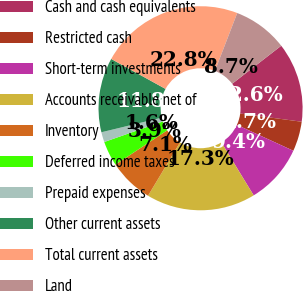<chart> <loc_0><loc_0><loc_500><loc_500><pie_chart><fcel>Cash and cash equivalents<fcel>Restricted cash<fcel>Short-term investments<fcel>Accounts receivable net of<fcel>Inventory<fcel>Deferred income taxes<fcel>Prepaid expenses<fcel>Other current assets<fcel>Total current assets<fcel>Land<nl><fcel>12.6%<fcel>4.73%<fcel>9.45%<fcel>17.32%<fcel>7.09%<fcel>3.94%<fcel>1.58%<fcel>11.81%<fcel>22.83%<fcel>8.66%<nl></chart> 